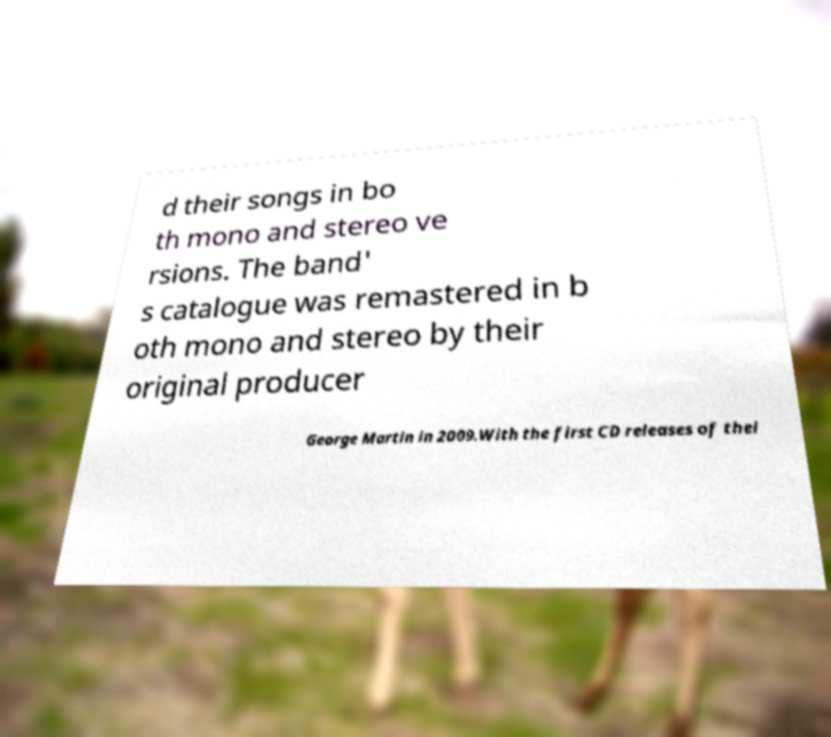What messages or text are displayed in this image? I need them in a readable, typed format. d their songs in bo th mono and stereo ve rsions. The band' s catalogue was remastered in b oth mono and stereo by their original producer George Martin in 2009.With the first CD releases of thei 